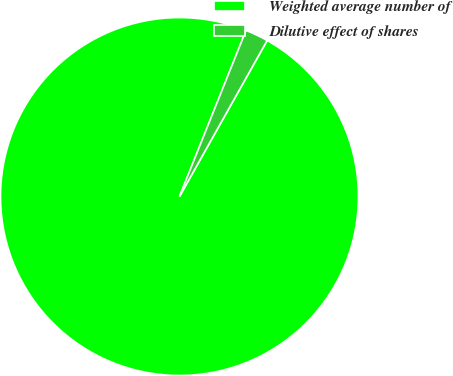<chart> <loc_0><loc_0><loc_500><loc_500><pie_chart><fcel>Weighted average number of<fcel>Dilutive effect of shares<nl><fcel>97.92%<fcel>2.08%<nl></chart> 